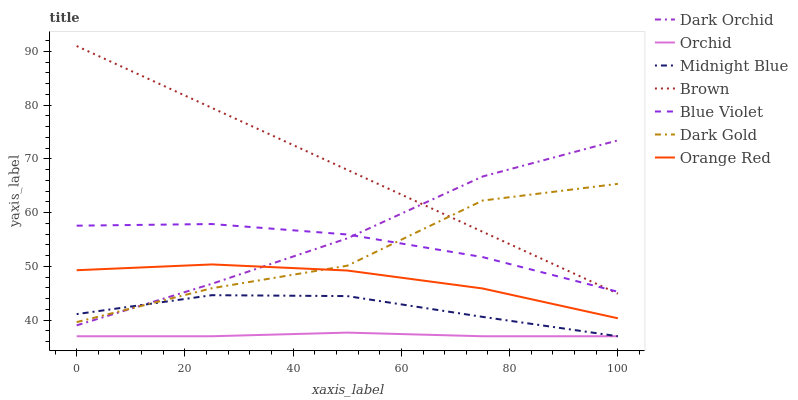Does Orchid have the minimum area under the curve?
Answer yes or no. Yes. Does Brown have the maximum area under the curve?
Answer yes or no. Yes. Does Midnight Blue have the minimum area under the curve?
Answer yes or no. No. Does Midnight Blue have the maximum area under the curve?
Answer yes or no. No. Is Brown the smoothest?
Answer yes or no. Yes. Is Dark Gold the roughest?
Answer yes or no. Yes. Is Midnight Blue the smoothest?
Answer yes or no. No. Is Midnight Blue the roughest?
Answer yes or no. No. Does Dark Gold have the lowest value?
Answer yes or no. No. Does Midnight Blue have the highest value?
Answer yes or no. No. Is Midnight Blue less than Brown?
Answer yes or no. Yes. Is Blue Violet greater than Orange Red?
Answer yes or no. Yes. Does Midnight Blue intersect Brown?
Answer yes or no. No. 